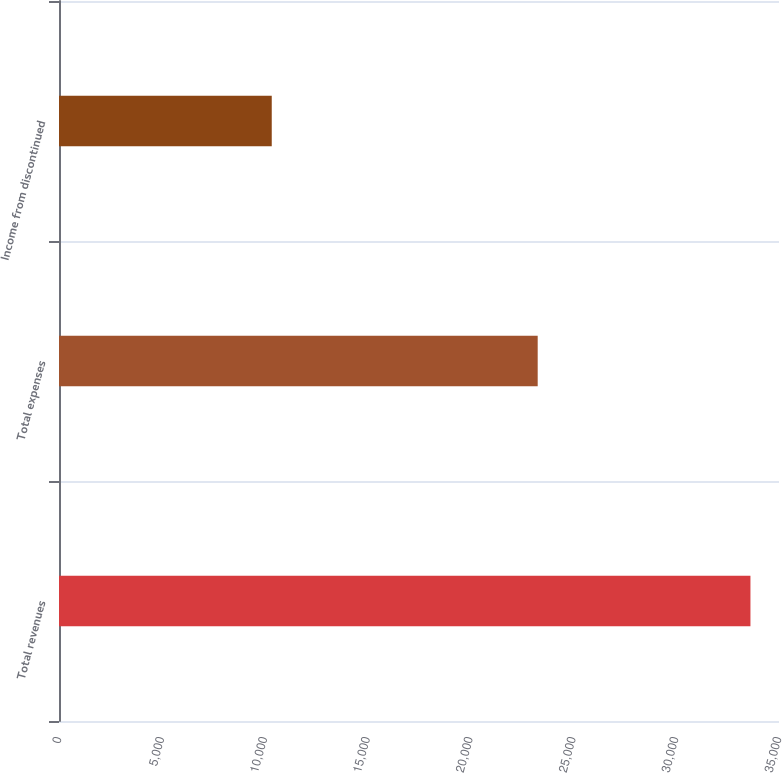Convert chart to OTSL. <chart><loc_0><loc_0><loc_500><loc_500><bar_chart><fcel>Total revenues<fcel>Total expenses<fcel>Income from discontinued<nl><fcel>33612<fcel>23270<fcel>10342<nl></chart> 